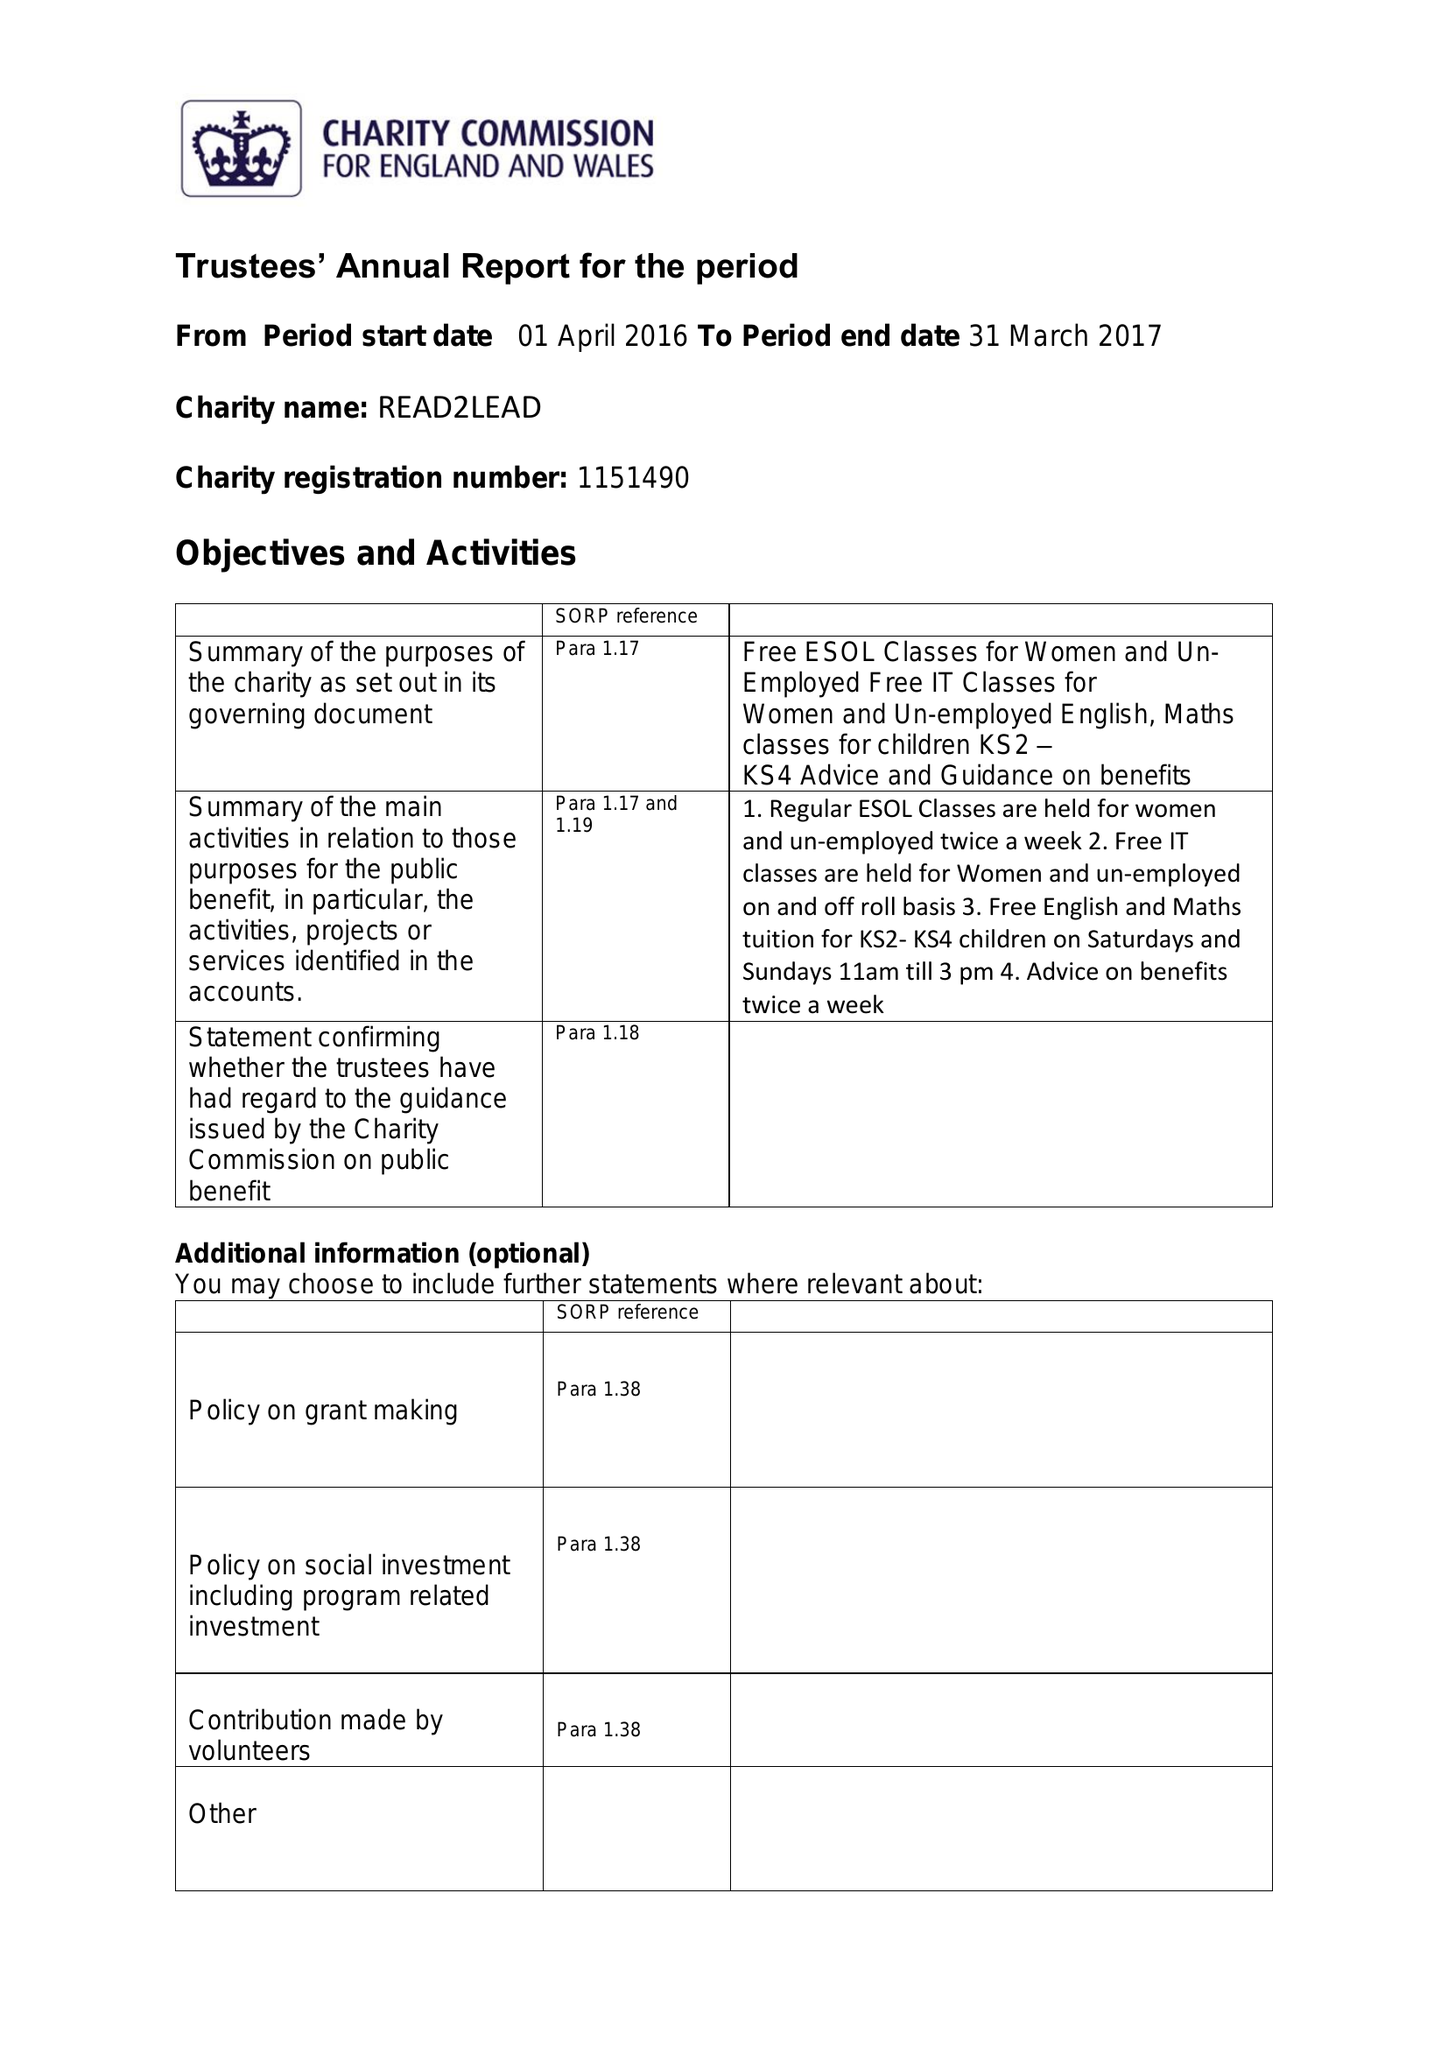What is the value for the spending_annually_in_british_pounds?
Answer the question using a single word or phrase. 20193.00 